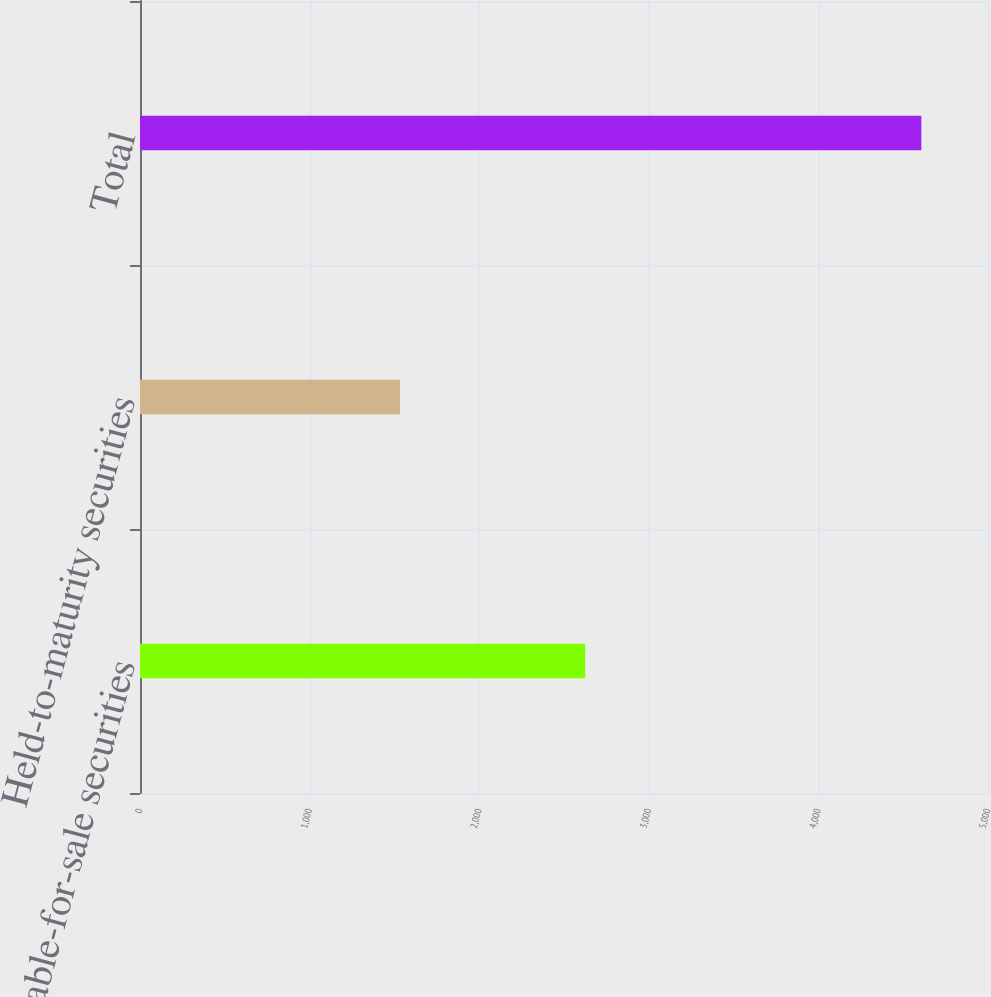Convert chart to OTSL. <chart><loc_0><loc_0><loc_500><loc_500><bar_chart><fcel>Available-for-sale securities<fcel>Held-to-maturity securities<fcel>Total<nl><fcel>2625<fcel>1533<fcel>4607<nl></chart> 